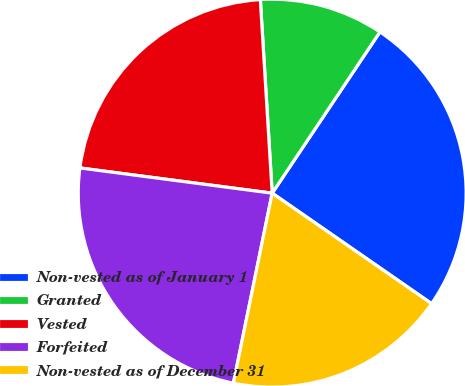Convert chart. <chart><loc_0><loc_0><loc_500><loc_500><pie_chart><fcel>Non-vested as of January 1<fcel>Granted<fcel>Vested<fcel>Forfeited<fcel>Non-vested as of December 31<nl><fcel>25.27%<fcel>10.35%<fcel>21.95%<fcel>23.87%<fcel>18.56%<nl></chart> 